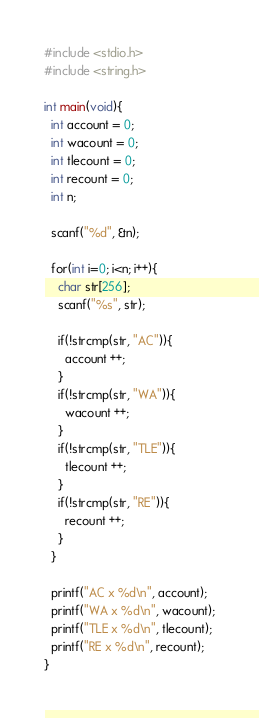<code> <loc_0><loc_0><loc_500><loc_500><_C_>#include <stdio.h>
#include <string.h>

int main(void){
  int account = 0;
  int wacount = 0;
  int tlecount = 0;
  int recount = 0;
  int n;

  scanf("%d", &n);

  for(int i=0; i<n; i++){
    char str[256];
    scanf("%s", str);
    
    if(!strcmp(str, "AC")){
      account ++;
    }
    if(!strcmp(str, "WA")){
      wacount ++;
    }
    if(!strcmp(str, "TLE")){
      tlecount ++;
    }
    if(!strcmp(str, "RE")){
      recount ++;
    }
  }

  printf("AC x %d\n", account);
  printf("WA x %d\n", wacount);
  printf("TLE x %d\n", tlecount);
  printf("RE x %d\n", recount);
}
</code> 